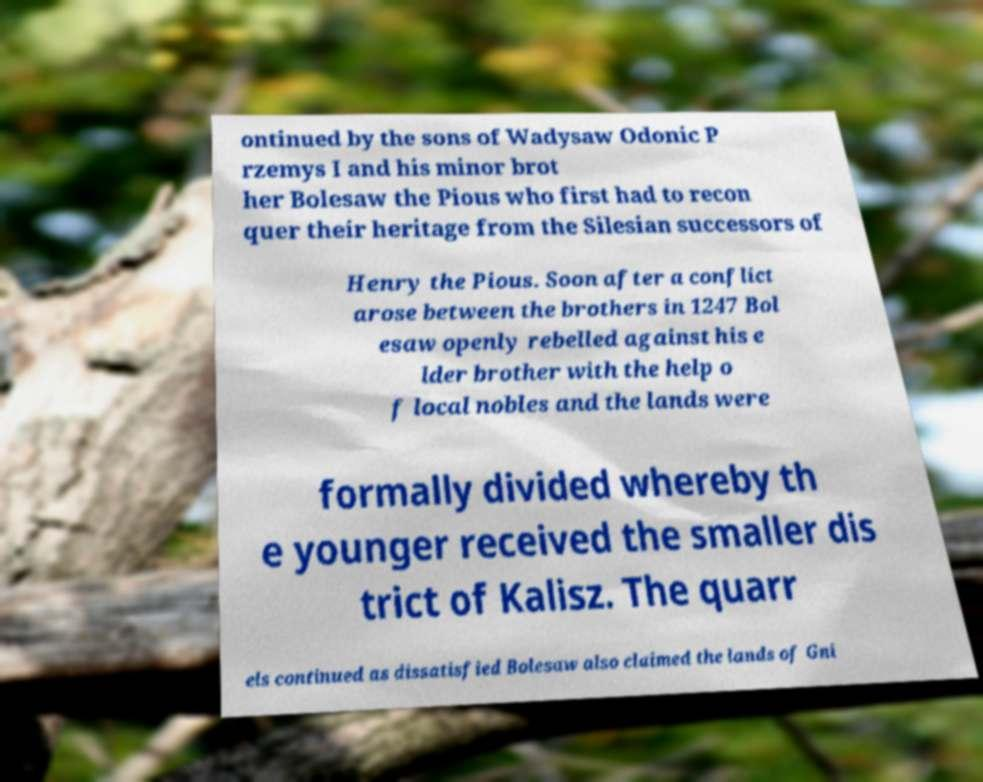Please identify and transcribe the text found in this image. ontinued by the sons of Wadysaw Odonic P rzemys I and his minor brot her Bolesaw the Pious who first had to recon quer their heritage from the Silesian successors of Henry the Pious. Soon after a conflict arose between the brothers in 1247 Bol esaw openly rebelled against his e lder brother with the help o f local nobles and the lands were formally divided whereby th e younger received the smaller dis trict of Kalisz. The quarr els continued as dissatisfied Bolesaw also claimed the lands of Gni 